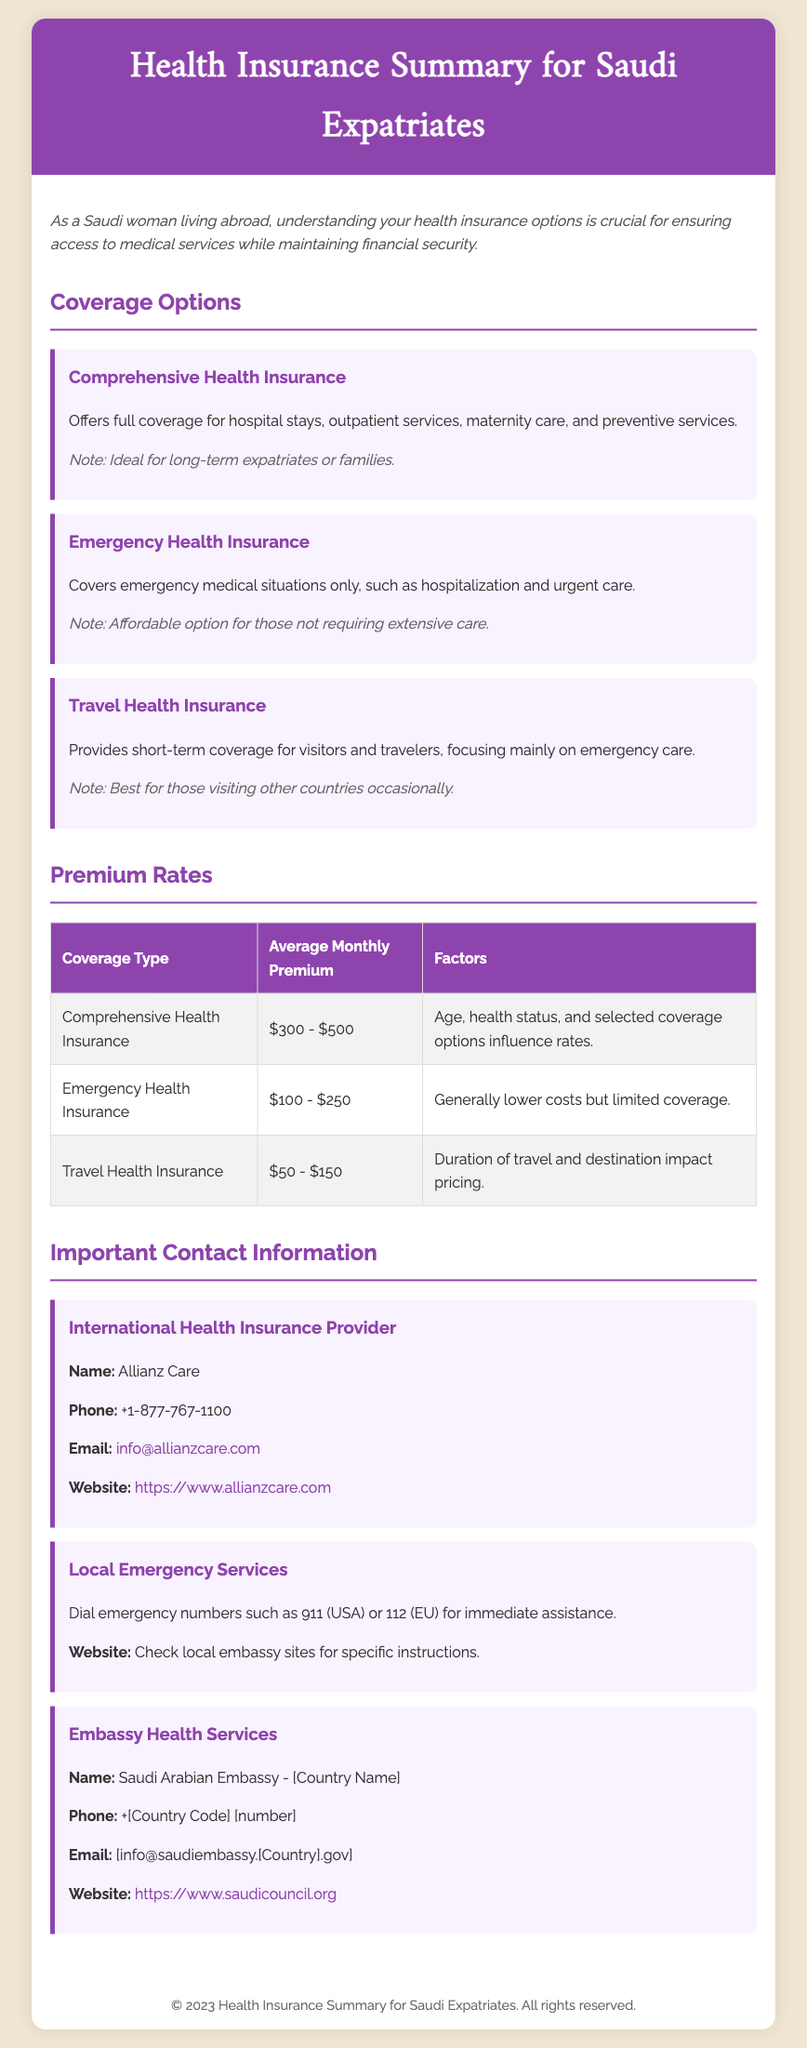What is the title of the document? The title of the document is the heading that describes its content, which is "Health Insurance Summary for Saudi Expatriates."
Answer: Health Insurance Summary for Saudi Expatriates What is the average monthly premium for Comprehensive Health Insurance? The average monthly premium for Comprehensive Health Insurance is listed in the table under that coverage type, which is $300 - $500.
Answer: $300 - $500 Which health insurance option is ideal for long-term expatriates or families? The document specifies that Comprehensive Health Insurance is ideal for long-term expatriates or families.
Answer: Comprehensive Health Insurance What is the contact email for Allianz Care? The email address for Allianz Care is mentioned in the contact information section as info@allianzcare.com.
Answer: info@allianzcare.com What is the monthly premium range for Emergency Health Insurance? The table provides the average monthly premium range for Emergency Health Insurance, which is $100 - $250.
Answer: $100 - $250 What does Travel Health Insurance focus primarily on? The document indicates that Travel Health Insurance focuses mainly on emergency care for short-term coverage.
Answer: Emergency care What does the introductory paragraph emphasize for Saudi women living abroad? The introduction stresses the importance of understanding health insurance options to ensure access to medical services while maintaining financial security.
Answer: Understanding health insurance options What phone number should be dialed for local emergency services in the USA? The document states that in the USA, 911 is the emergency number to dial for immediate assistance.
Answer: 911 What is the website for the Saudi Arabian Embassy? The contact information includes the website for the Saudi Arabian Embassy as https://www.saudicouncil.org.
Answer: https://www.saudicouncil.org 